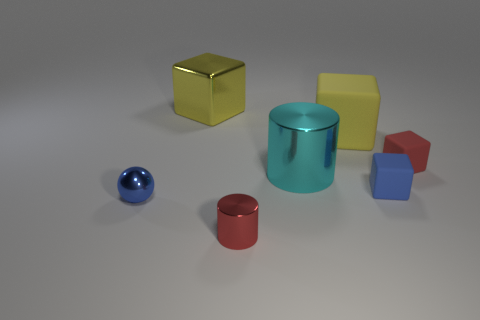Are there any big cylinders behind the yellow object behind the big matte thing?
Provide a succinct answer. No. What number of tiny blue blocks are behind the thing behind the big yellow matte cube?
Provide a short and direct response. 0. What material is the blue block that is the same size as the red metal object?
Your answer should be compact. Rubber. Is the shape of the shiny object behind the large cylinder the same as  the tiny blue shiny thing?
Keep it short and to the point. No. Is the number of rubber cubes in front of the small blue metallic thing greater than the number of tiny cylinders to the right of the large cyan metallic thing?
Offer a terse response. No. What number of balls are made of the same material as the large cyan cylinder?
Make the answer very short. 1. Is the size of the red block the same as the yellow shiny block?
Offer a terse response. No. What is the color of the big cylinder?
Your answer should be compact. Cyan. What number of objects are either metallic blocks or big cubes?
Offer a terse response. 2. Is there another metal object that has the same shape as the large yellow metal object?
Make the answer very short. No. 